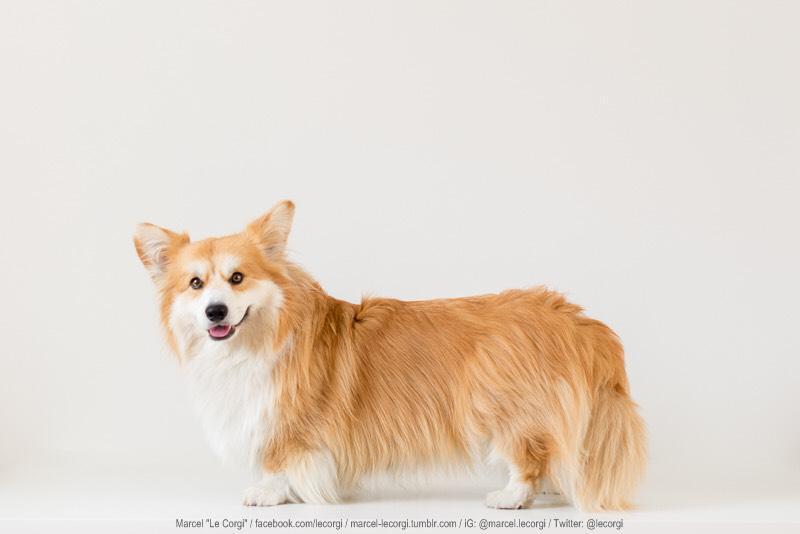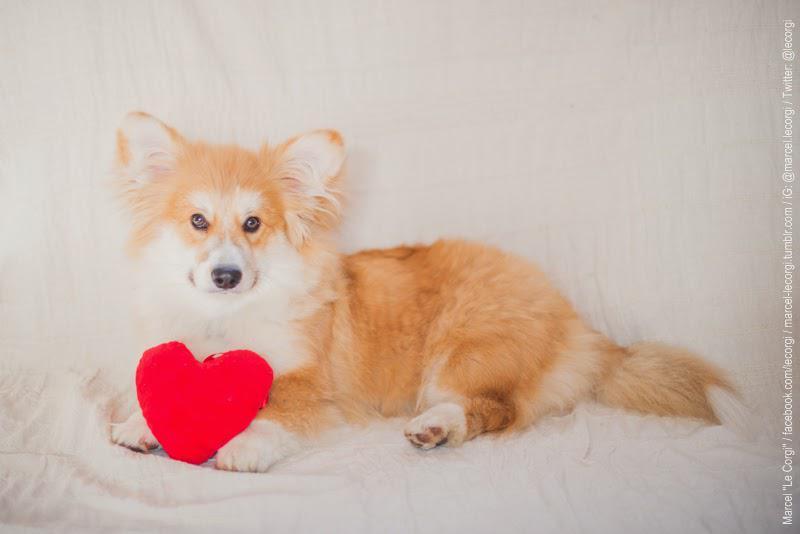The first image is the image on the left, the second image is the image on the right. For the images shown, is this caption "One photo shows a dog outdoors." true? Answer yes or no. No. The first image is the image on the left, the second image is the image on the right. Assess this claim about the two images: "One of the dogs is shown with holiday decoration.". Correct or not? Answer yes or no. Yes. 